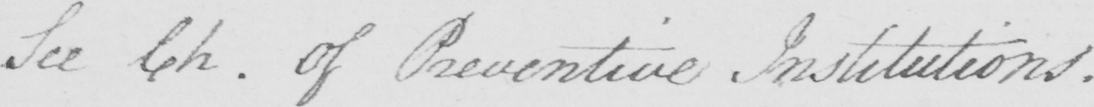Transcribe the text shown in this historical manuscript line. See Ch . Of Preventive Institutions . 